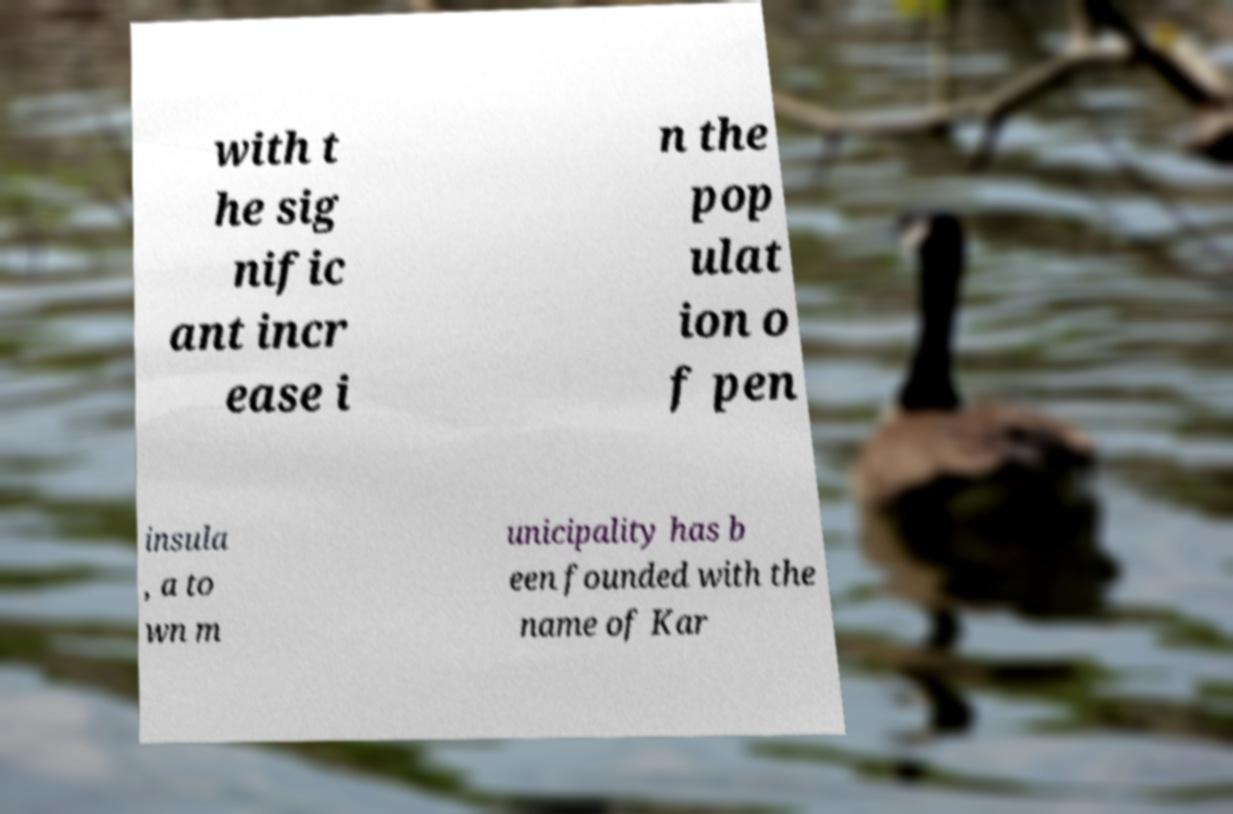Please identify and transcribe the text found in this image. with t he sig nific ant incr ease i n the pop ulat ion o f pen insula , a to wn m unicipality has b een founded with the name of Kar 